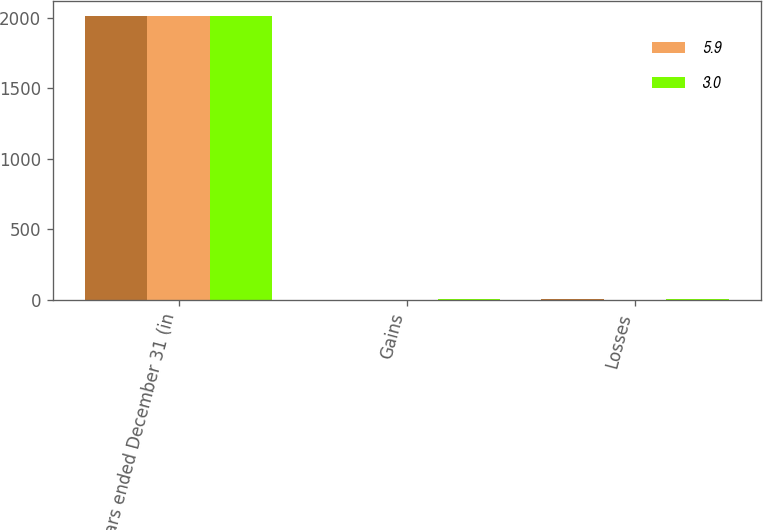Convert chart to OTSL. <chart><loc_0><loc_0><loc_500><loc_500><stacked_bar_chart><ecel><fcel>Years ended December 31 (in<fcel>Gains<fcel>Losses<nl><fcel>nan<fcel>2016<fcel>0.2<fcel>6.1<nl><fcel>5.9<fcel>2015<fcel>0.3<fcel>0.3<nl><fcel>3<fcel>2014<fcel>4.4<fcel>1.4<nl></chart> 